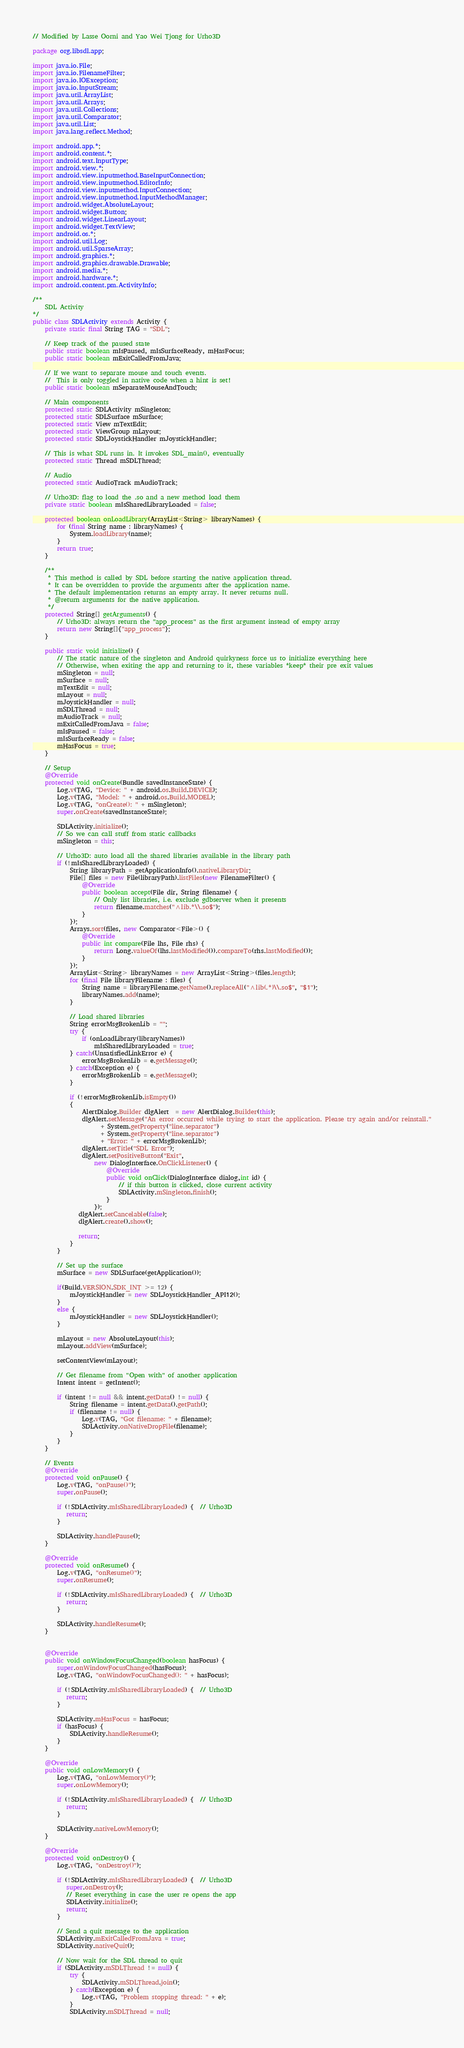<code> <loc_0><loc_0><loc_500><loc_500><_Java_>// Modified by Lasse Oorni and Yao Wei Tjong for Urho3D

package org.libsdl.app;

import java.io.File;
import java.io.FilenameFilter;
import java.io.IOException;
import java.io.InputStream;
import java.util.ArrayList;
import java.util.Arrays;
import java.util.Collections;
import java.util.Comparator;
import java.util.List;
import java.lang.reflect.Method;

import android.app.*;
import android.content.*;
import android.text.InputType;
import android.view.*;
import android.view.inputmethod.BaseInputConnection;
import android.view.inputmethod.EditorInfo;
import android.view.inputmethod.InputConnection;
import android.view.inputmethod.InputMethodManager;
import android.widget.AbsoluteLayout;
import android.widget.Button;
import android.widget.LinearLayout;
import android.widget.TextView;
import android.os.*;
import android.util.Log;
import android.util.SparseArray;
import android.graphics.*;
import android.graphics.drawable.Drawable;
import android.media.*;
import android.hardware.*;
import android.content.pm.ActivityInfo;

/**
    SDL Activity
*/
public class SDLActivity extends Activity {
    private static final String TAG = "SDL";

    // Keep track of the paused state
    public static boolean mIsPaused, mIsSurfaceReady, mHasFocus;
    public static boolean mExitCalledFromJava;

    // If we want to separate mouse and touch events.
    //  This is only toggled in native code when a hint is set!
    public static boolean mSeparateMouseAndTouch;

    // Main components
    protected static SDLActivity mSingleton;
    protected static SDLSurface mSurface;
    protected static View mTextEdit;
    protected static ViewGroup mLayout;
    protected static SDLJoystickHandler mJoystickHandler;

    // This is what SDL runs in. It invokes SDL_main(), eventually
    protected static Thread mSDLThread;

    // Audio
    protected static AudioTrack mAudioTrack;

    // Urho3D: flag to load the .so and a new method load them
    private static boolean mIsSharedLibraryLoaded = false;

    protected boolean onLoadLibrary(ArrayList<String> libraryNames) {
        for (final String name : libraryNames) {
            System.loadLibrary(name);
        }
        return true;
    }
    
    /**
     * This method is called by SDL before starting the native application thread.
     * It can be overridden to provide the arguments after the application name.
     * The default implementation returns an empty array. It never returns null.
     * @return arguments for the native application.
     */
    protected String[] getArguments() {
        // Urho3D: always return the "app_process" as the first argument instead of empty array
        return new String[]{"app_process"};
    }

    public static void initialize() {
        // The static nature of the singleton and Android quirkyness force us to initialize everything here
        // Otherwise, when exiting the app and returning to it, these variables *keep* their pre exit values
        mSingleton = null;
        mSurface = null;
        mTextEdit = null;
        mLayout = null;
        mJoystickHandler = null;
        mSDLThread = null;
        mAudioTrack = null;
        mExitCalledFromJava = false;
        mIsPaused = false;
        mIsSurfaceReady = false;
        mHasFocus = true;
    }

    // Setup
    @Override
    protected void onCreate(Bundle savedInstanceState) {
        Log.v(TAG, "Device: " + android.os.Build.DEVICE);
        Log.v(TAG, "Model: " + android.os.Build.MODEL);
        Log.v(TAG, "onCreate(): " + mSingleton);
        super.onCreate(savedInstanceState);

        SDLActivity.initialize();
        // So we can call stuff from static callbacks
        mSingleton = this;

        // Urho3D: auto load all the shared libraries available in the library path
        if (!mIsSharedLibraryLoaded) {
            String libraryPath = getApplicationInfo().nativeLibraryDir;
            File[] files = new File(libraryPath).listFiles(new FilenameFilter() {
                @Override
                public boolean accept(File dir, String filename) {
                    // Only list libraries, i.e. exclude gdbserver when it presents
                    return filename.matches("^lib.*\\.so$");
                }
            });
            Arrays.sort(files, new Comparator<File>() {
                @Override
                public int compare(File lhs, File rhs) {
                    return Long.valueOf(lhs.lastModified()).compareTo(rhs.lastModified());
                }
            });
            ArrayList<String> libraryNames = new ArrayList<String>(files.length);
            for (final File libraryFilename : files) {
                String name = libraryFilename.getName().replaceAll("^lib(.*)\\.so$", "$1");
                libraryNames.add(name);
            }

            // Load shared libraries
            String errorMsgBrokenLib = "";
            try {
                if (onLoadLibrary(libraryNames))
                    mIsSharedLibraryLoaded = true;
            } catch(UnsatisfiedLinkError e) {
                errorMsgBrokenLib = e.getMessage();
            } catch(Exception e) {
                errorMsgBrokenLib = e.getMessage();
            }

            if (!errorMsgBrokenLib.isEmpty())
            {
                AlertDialog.Builder dlgAlert  = new AlertDialog.Builder(this);
                dlgAlert.setMessage("An error occurred while trying to start the application. Please try again and/or reinstall."
                      + System.getProperty("line.separator")
                      + System.getProperty("line.separator")
                      + "Error: " + errorMsgBrokenLib);
                dlgAlert.setTitle("SDL Error");
                dlgAlert.setPositiveButton("Exit",
                    new DialogInterface.OnClickListener() {
                        @Override
                        public void onClick(DialogInterface dialog,int id) {
                            // if this button is clicked, close current activity
                            SDLActivity.mSingleton.finish();
                        }
                    });
               dlgAlert.setCancelable(false);
               dlgAlert.create().show();

               return;
            }
        }

        // Set up the surface
        mSurface = new SDLSurface(getApplication());

        if(Build.VERSION.SDK_INT >= 12) {
            mJoystickHandler = new SDLJoystickHandler_API12();
        }
        else {
            mJoystickHandler = new SDLJoystickHandler();
        }

        mLayout = new AbsoluteLayout(this);
        mLayout.addView(mSurface);

        setContentView(mLayout);
        
        // Get filename from "Open with" of another application
        Intent intent = getIntent();

        if (intent != null && intent.getData() != null) {
            String filename = intent.getData().getPath();
            if (filename != null) {
                Log.v(TAG, "Got filename: " + filename);
                SDLActivity.onNativeDropFile(filename);
            }
        }
    }

    // Events
    @Override
    protected void onPause() {
        Log.v(TAG, "onPause()");
        super.onPause();

        if (!SDLActivity.mIsSharedLibraryLoaded) {  // Urho3D
           return;
        }

        SDLActivity.handlePause();
    }

    @Override
    protected void onResume() {
        Log.v(TAG, "onResume()");
        super.onResume();

        if (!SDLActivity.mIsSharedLibraryLoaded) {  // Urho3D
           return;
        }

        SDLActivity.handleResume();
    }


    @Override
    public void onWindowFocusChanged(boolean hasFocus) {
        super.onWindowFocusChanged(hasFocus);
        Log.v(TAG, "onWindowFocusChanged(): " + hasFocus);

        if (!SDLActivity.mIsSharedLibraryLoaded) {  // Urho3D
           return;
        }

        SDLActivity.mHasFocus = hasFocus;
        if (hasFocus) {
            SDLActivity.handleResume();
        }
    }

    @Override
    public void onLowMemory() {
        Log.v(TAG, "onLowMemory()");
        super.onLowMemory();

        if (!SDLActivity.mIsSharedLibraryLoaded) {  // Urho3D
           return;
        }

        SDLActivity.nativeLowMemory();
    }

    @Override
    protected void onDestroy() {
        Log.v(TAG, "onDestroy()");

        if (!SDLActivity.mIsSharedLibraryLoaded) {  // Urho3D
           super.onDestroy();
           // Reset everything in case the user re opens the app
           SDLActivity.initialize();
           return;
        }

        // Send a quit message to the application
        SDLActivity.mExitCalledFromJava = true;
        SDLActivity.nativeQuit();

        // Now wait for the SDL thread to quit
        if (SDLActivity.mSDLThread != null) {
            try {
                SDLActivity.mSDLThread.join();
            } catch(Exception e) {
                Log.v(TAG, "Problem stopping thread: " + e);
            }
            SDLActivity.mSDLThread = null;
</code> 